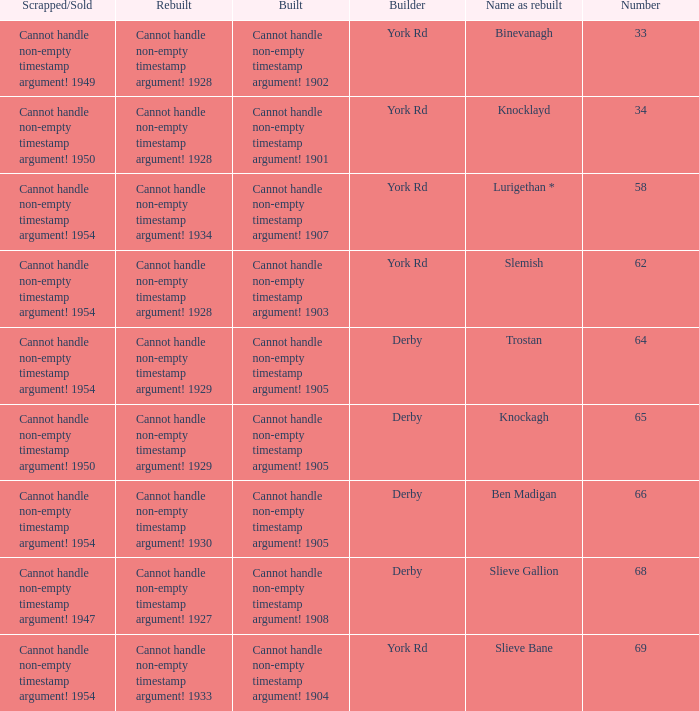Which Scrapped/Sold has a Builder of derby, and a Name as rebuilt of ben madigan? Cannot handle non-empty timestamp argument! 1954. 